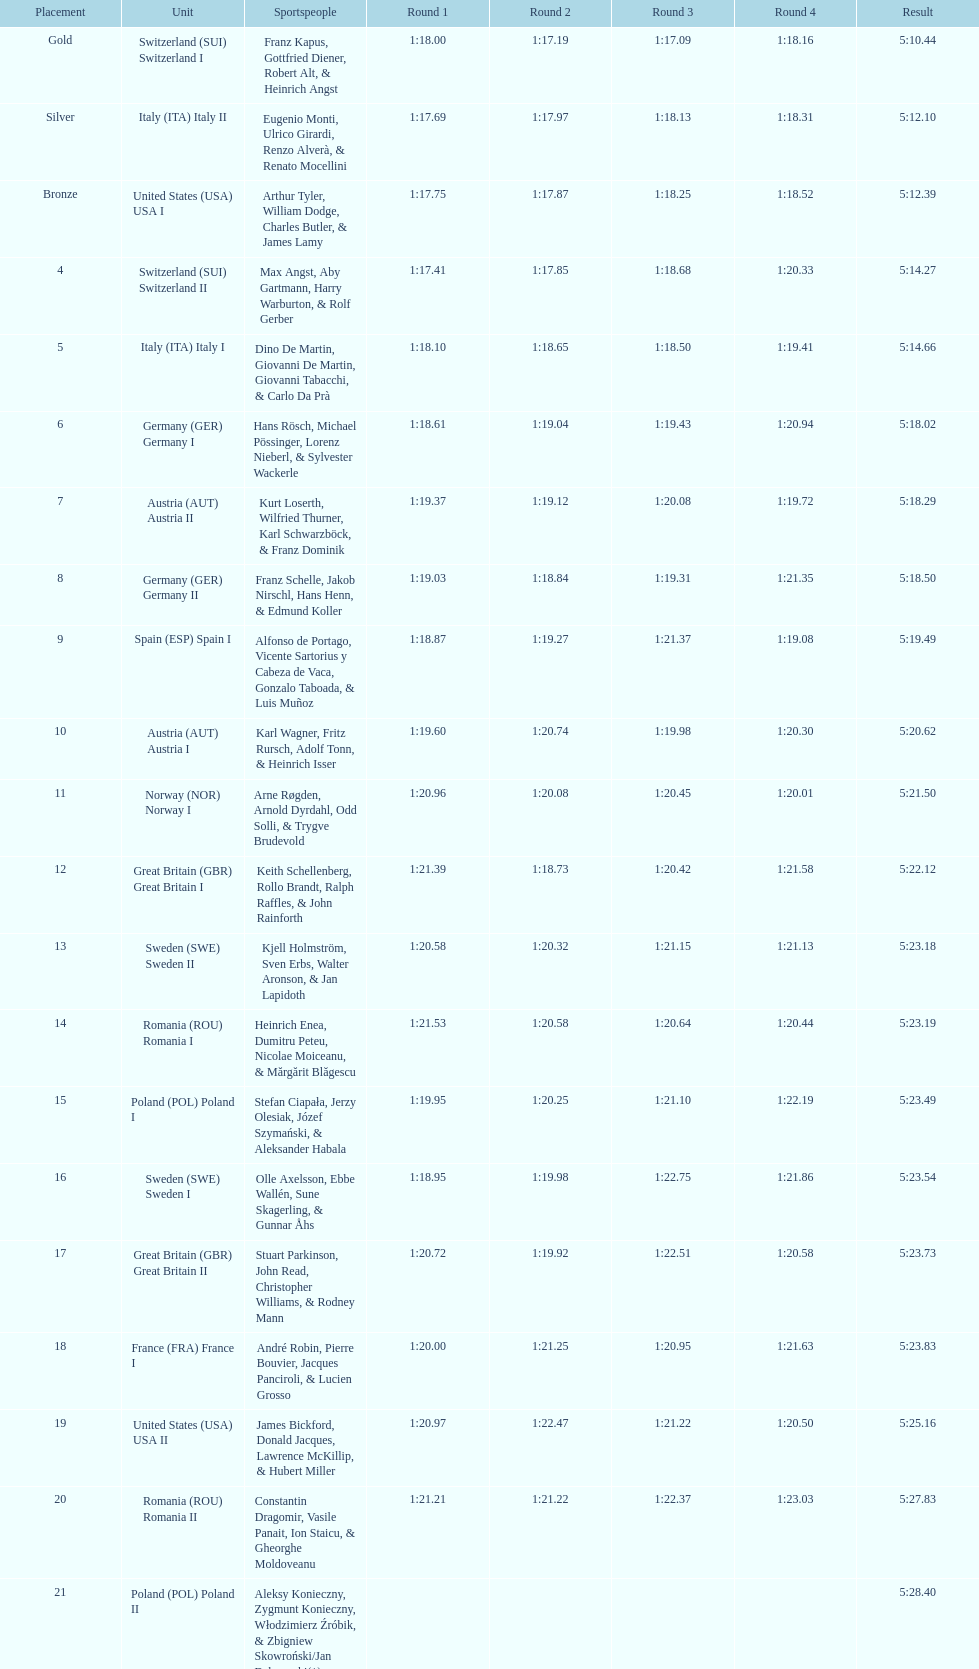What was the number of teams in germany? 2. 